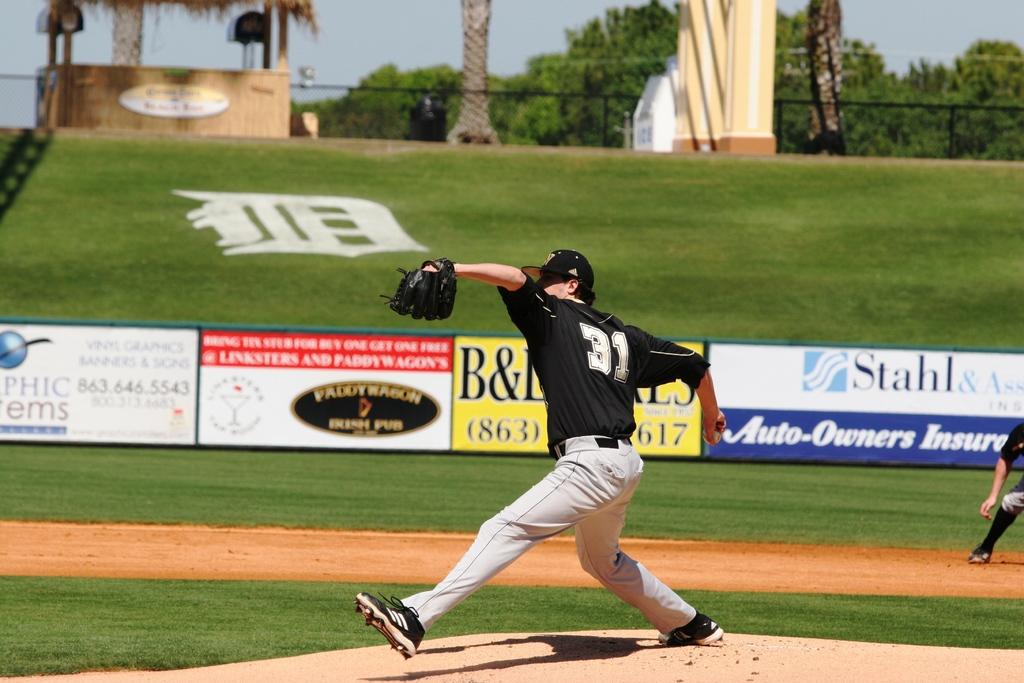What is the car insurance company sponsor?
Keep it short and to the point. Stahl. 